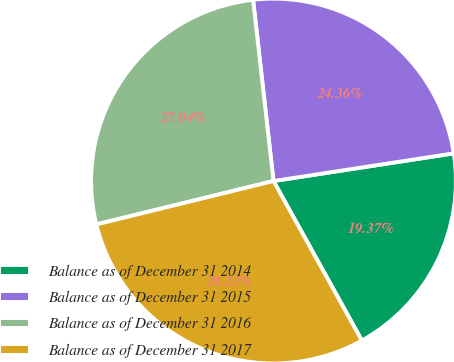Convert chart. <chart><loc_0><loc_0><loc_500><loc_500><pie_chart><fcel>Balance as of December 31 2014<fcel>Balance as of December 31 2015<fcel>Balance as of December 31 2016<fcel>Balance as of December 31 2017<nl><fcel>19.37%<fcel>24.36%<fcel>27.04%<fcel>29.23%<nl></chart> 